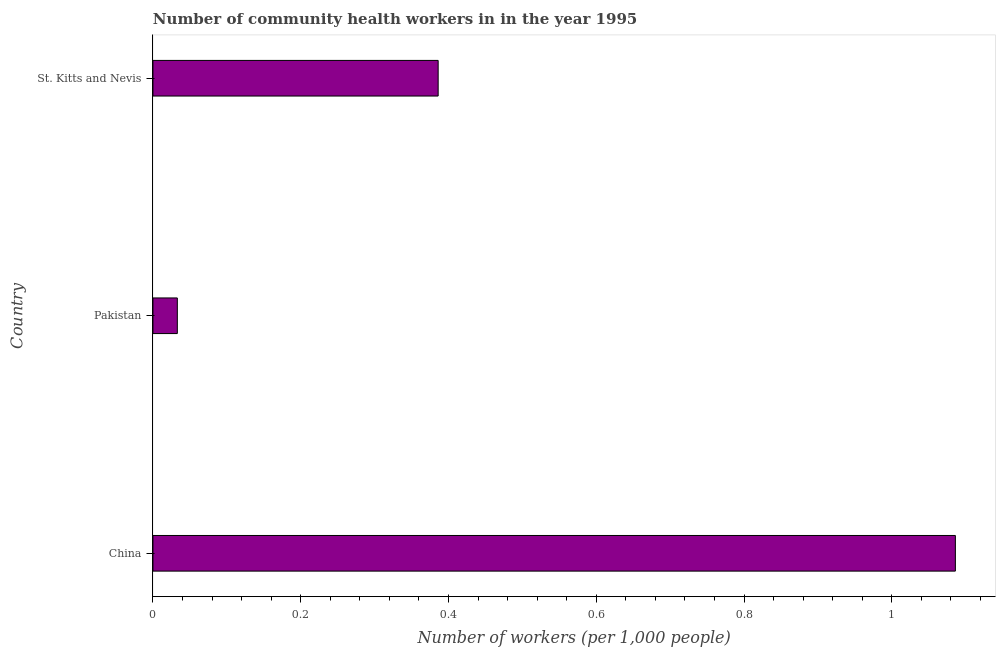Does the graph contain grids?
Your response must be concise. No. What is the title of the graph?
Offer a terse response. Number of community health workers in in the year 1995. What is the label or title of the X-axis?
Keep it short and to the point. Number of workers (per 1,0 people). What is the label or title of the Y-axis?
Your response must be concise. Country. What is the number of community health workers in Pakistan?
Your response must be concise. 0.03. Across all countries, what is the maximum number of community health workers?
Offer a terse response. 1.09. Across all countries, what is the minimum number of community health workers?
Give a very brief answer. 0.03. In which country was the number of community health workers minimum?
Keep it short and to the point. Pakistan. What is the sum of the number of community health workers?
Make the answer very short. 1.5. What is the difference between the number of community health workers in Pakistan and St. Kitts and Nevis?
Ensure brevity in your answer.  -0.35. What is the average number of community health workers per country?
Your answer should be very brief. 0.5. What is the median number of community health workers?
Offer a very short reply. 0.39. In how many countries, is the number of community health workers greater than 0.24 ?
Offer a very short reply. 2. What is the ratio of the number of community health workers in China to that in Pakistan?
Make the answer very short. 32.91. Is the number of community health workers in China less than that in St. Kitts and Nevis?
Your answer should be compact. No. Is the sum of the number of community health workers in China and Pakistan greater than the maximum number of community health workers across all countries?
Offer a terse response. Yes. How many bars are there?
Provide a short and direct response. 3. Are all the bars in the graph horizontal?
Keep it short and to the point. Yes. How many countries are there in the graph?
Make the answer very short. 3. What is the Number of workers (per 1,000 people) in China?
Your answer should be very brief. 1.09. What is the Number of workers (per 1,000 people) in Pakistan?
Offer a very short reply. 0.03. What is the Number of workers (per 1,000 people) of St. Kitts and Nevis?
Keep it short and to the point. 0.39. What is the difference between the Number of workers (per 1,000 people) in China and Pakistan?
Your answer should be very brief. 1.05. What is the difference between the Number of workers (per 1,000 people) in Pakistan and St. Kitts and Nevis?
Offer a terse response. -0.35. What is the ratio of the Number of workers (per 1,000 people) in China to that in Pakistan?
Give a very brief answer. 32.91. What is the ratio of the Number of workers (per 1,000 people) in China to that in St. Kitts and Nevis?
Provide a succinct answer. 2.81. What is the ratio of the Number of workers (per 1,000 people) in Pakistan to that in St. Kitts and Nevis?
Your response must be concise. 0.09. 